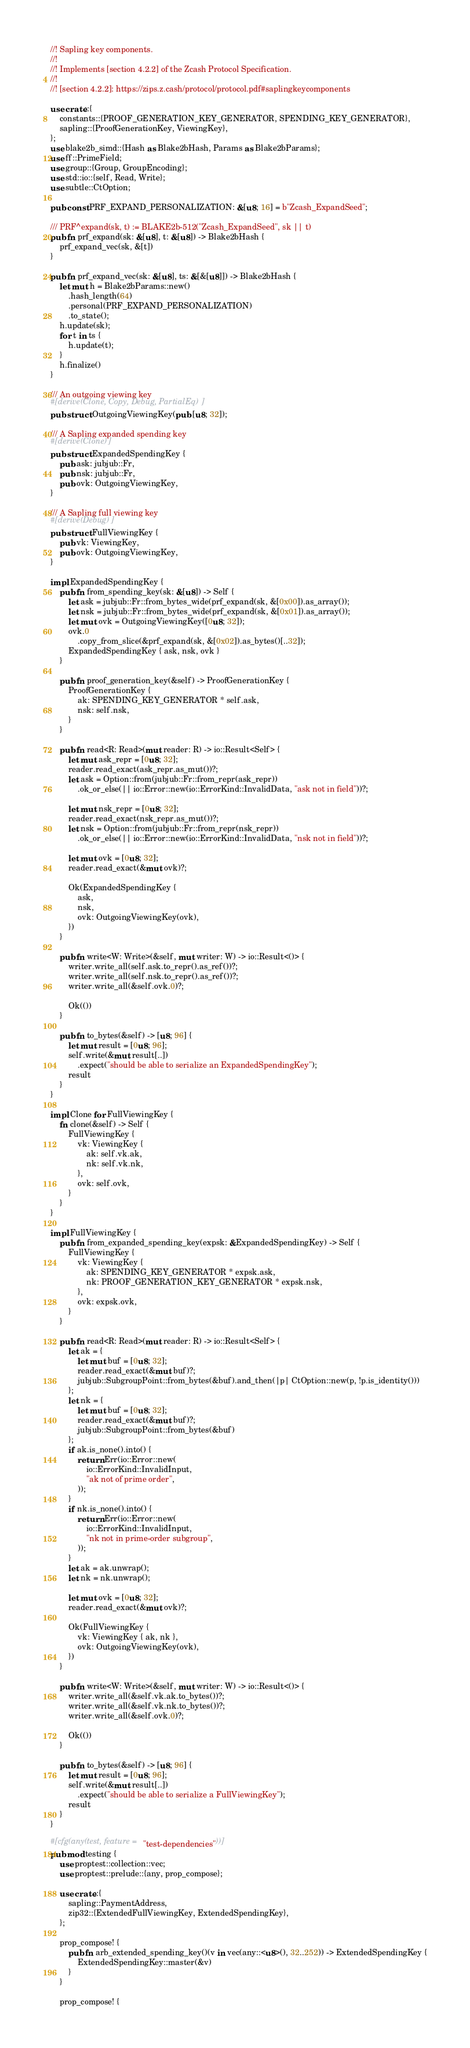Convert code to text. <code><loc_0><loc_0><loc_500><loc_500><_Rust_>//! Sapling key components.
//!
//! Implements [section 4.2.2] of the Zcash Protocol Specification.
//!
//! [section 4.2.2]: https://zips.z.cash/protocol/protocol.pdf#saplingkeycomponents

use crate::{
    constants::{PROOF_GENERATION_KEY_GENERATOR, SPENDING_KEY_GENERATOR},
    sapling::{ProofGenerationKey, ViewingKey},
};
use blake2b_simd::{Hash as Blake2bHash, Params as Blake2bParams};
use ff::PrimeField;
use group::{Group, GroupEncoding};
use std::io::{self, Read, Write};
use subtle::CtOption;

pub const PRF_EXPAND_PERSONALIZATION: &[u8; 16] = b"Zcash_ExpandSeed";

/// PRF^expand(sk, t) := BLAKE2b-512("Zcash_ExpandSeed", sk || t)
pub fn prf_expand(sk: &[u8], t: &[u8]) -> Blake2bHash {
    prf_expand_vec(sk, &[t])
}

pub fn prf_expand_vec(sk: &[u8], ts: &[&[u8]]) -> Blake2bHash {
    let mut h = Blake2bParams::new()
        .hash_length(64)
        .personal(PRF_EXPAND_PERSONALIZATION)
        .to_state();
    h.update(sk);
    for t in ts {
        h.update(t);
    }
    h.finalize()
}

/// An outgoing viewing key
#[derive(Clone, Copy, Debug, PartialEq)]
pub struct OutgoingViewingKey(pub [u8; 32]);

/// A Sapling expanded spending key
#[derive(Clone)]
pub struct ExpandedSpendingKey {
    pub ask: jubjub::Fr,
    pub nsk: jubjub::Fr,
    pub ovk: OutgoingViewingKey,
}

/// A Sapling full viewing key
#[derive(Debug)]
pub struct FullViewingKey {
    pub vk: ViewingKey,
    pub ovk: OutgoingViewingKey,
}

impl ExpandedSpendingKey {
    pub fn from_spending_key(sk: &[u8]) -> Self {
        let ask = jubjub::Fr::from_bytes_wide(prf_expand(sk, &[0x00]).as_array());
        let nsk = jubjub::Fr::from_bytes_wide(prf_expand(sk, &[0x01]).as_array());
        let mut ovk = OutgoingViewingKey([0u8; 32]);
        ovk.0
            .copy_from_slice(&prf_expand(sk, &[0x02]).as_bytes()[..32]);
        ExpandedSpendingKey { ask, nsk, ovk }
    }

    pub fn proof_generation_key(&self) -> ProofGenerationKey {
        ProofGenerationKey {
            ak: SPENDING_KEY_GENERATOR * self.ask,
            nsk: self.nsk,
        }
    }

    pub fn read<R: Read>(mut reader: R) -> io::Result<Self> {
        let mut ask_repr = [0u8; 32];
        reader.read_exact(ask_repr.as_mut())?;
        let ask = Option::from(jubjub::Fr::from_repr(ask_repr))
            .ok_or_else(|| io::Error::new(io::ErrorKind::InvalidData, "ask not in field"))?;

        let mut nsk_repr = [0u8; 32];
        reader.read_exact(nsk_repr.as_mut())?;
        let nsk = Option::from(jubjub::Fr::from_repr(nsk_repr))
            .ok_or_else(|| io::Error::new(io::ErrorKind::InvalidData, "nsk not in field"))?;

        let mut ovk = [0u8; 32];
        reader.read_exact(&mut ovk)?;

        Ok(ExpandedSpendingKey {
            ask,
            nsk,
            ovk: OutgoingViewingKey(ovk),
        })
    }

    pub fn write<W: Write>(&self, mut writer: W) -> io::Result<()> {
        writer.write_all(self.ask.to_repr().as_ref())?;
        writer.write_all(self.nsk.to_repr().as_ref())?;
        writer.write_all(&self.ovk.0)?;

        Ok(())
    }

    pub fn to_bytes(&self) -> [u8; 96] {
        let mut result = [0u8; 96];
        self.write(&mut result[..])
            .expect("should be able to serialize an ExpandedSpendingKey");
        result
    }
}

impl Clone for FullViewingKey {
    fn clone(&self) -> Self {
        FullViewingKey {
            vk: ViewingKey {
                ak: self.vk.ak,
                nk: self.vk.nk,
            },
            ovk: self.ovk,
        }
    }
}

impl FullViewingKey {
    pub fn from_expanded_spending_key(expsk: &ExpandedSpendingKey) -> Self {
        FullViewingKey {
            vk: ViewingKey {
                ak: SPENDING_KEY_GENERATOR * expsk.ask,
                nk: PROOF_GENERATION_KEY_GENERATOR * expsk.nsk,
            },
            ovk: expsk.ovk,
        }
    }

    pub fn read<R: Read>(mut reader: R) -> io::Result<Self> {
        let ak = {
            let mut buf = [0u8; 32];
            reader.read_exact(&mut buf)?;
            jubjub::SubgroupPoint::from_bytes(&buf).and_then(|p| CtOption::new(p, !p.is_identity()))
        };
        let nk = {
            let mut buf = [0u8; 32];
            reader.read_exact(&mut buf)?;
            jubjub::SubgroupPoint::from_bytes(&buf)
        };
        if ak.is_none().into() {
            return Err(io::Error::new(
                io::ErrorKind::InvalidInput,
                "ak not of prime order",
            ));
        }
        if nk.is_none().into() {
            return Err(io::Error::new(
                io::ErrorKind::InvalidInput,
                "nk not in prime-order subgroup",
            ));
        }
        let ak = ak.unwrap();
        let nk = nk.unwrap();

        let mut ovk = [0u8; 32];
        reader.read_exact(&mut ovk)?;

        Ok(FullViewingKey {
            vk: ViewingKey { ak, nk },
            ovk: OutgoingViewingKey(ovk),
        })
    }

    pub fn write<W: Write>(&self, mut writer: W) -> io::Result<()> {
        writer.write_all(&self.vk.ak.to_bytes())?;
        writer.write_all(&self.vk.nk.to_bytes())?;
        writer.write_all(&self.ovk.0)?;

        Ok(())
    }

    pub fn to_bytes(&self) -> [u8; 96] {
        let mut result = [0u8; 96];
        self.write(&mut result[..])
            .expect("should be able to serialize a FullViewingKey");
        result
    }
}

#[cfg(any(test, feature = "test-dependencies"))]
pub mod testing {
    use proptest::collection::vec;
    use proptest::prelude::{any, prop_compose};

    use crate::{
        sapling::PaymentAddress,
        zip32::{ExtendedFullViewingKey, ExtendedSpendingKey},
    };

    prop_compose! {
        pub fn arb_extended_spending_key()(v in vec(any::<u8>(), 32..252)) -> ExtendedSpendingKey {
            ExtendedSpendingKey::master(&v)
        }
    }

    prop_compose! {</code> 